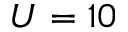Convert formula to latex. <formula><loc_0><loc_0><loc_500><loc_500>U = 1 0</formula> 